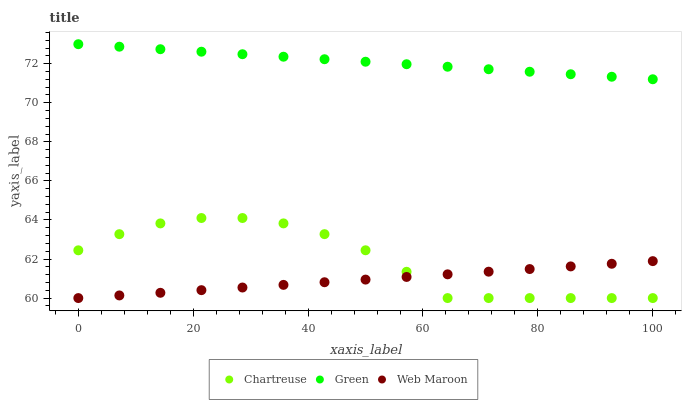Does Web Maroon have the minimum area under the curve?
Answer yes or no. Yes. Does Green have the maximum area under the curve?
Answer yes or no. Yes. Does Chartreuse have the minimum area under the curve?
Answer yes or no. No. Does Chartreuse have the maximum area under the curve?
Answer yes or no. No. Is Web Maroon the smoothest?
Answer yes or no. Yes. Is Chartreuse the roughest?
Answer yes or no. Yes. Is Green the smoothest?
Answer yes or no. No. Is Green the roughest?
Answer yes or no. No. Does Web Maroon have the lowest value?
Answer yes or no. Yes. Does Green have the lowest value?
Answer yes or no. No. Does Green have the highest value?
Answer yes or no. Yes. Does Chartreuse have the highest value?
Answer yes or no. No. Is Chartreuse less than Green?
Answer yes or no. Yes. Is Green greater than Chartreuse?
Answer yes or no. Yes. Does Web Maroon intersect Chartreuse?
Answer yes or no. Yes. Is Web Maroon less than Chartreuse?
Answer yes or no. No. Is Web Maroon greater than Chartreuse?
Answer yes or no. No. Does Chartreuse intersect Green?
Answer yes or no. No. 